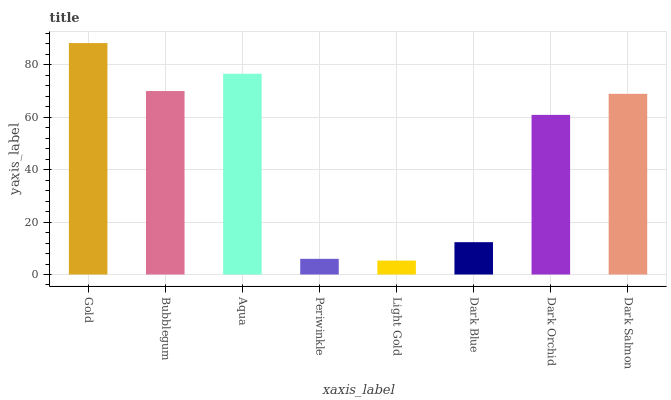Is Light Gold the minimum?
Answer yes or no. Yes. Is Gold the maximum?
Answer yes or no. Yes. Is Bubblegum the minimum?
Answer yes or no. No. Is Bubblegum the maximum?
Answer yes or no. No. Is Gold greater than Bubblegum?
Answer yes or no. Yes. Is Bubblegum less than Gold?
Answer yes or no. Yes. Is Bubblegum greater than Gold?
Answer yes or no. No. Is Gold less than Bubblegum?
Answer yes or no. No. Is Dark Salmon the high median?
Answer yes or no. Yes. Is Dark Orchid the low median?
Answer yes or no. Yes. Is Aqua the high median?
Answer yes or no. No. Is Dark Blue the low median?
Answer yes or no. No. 